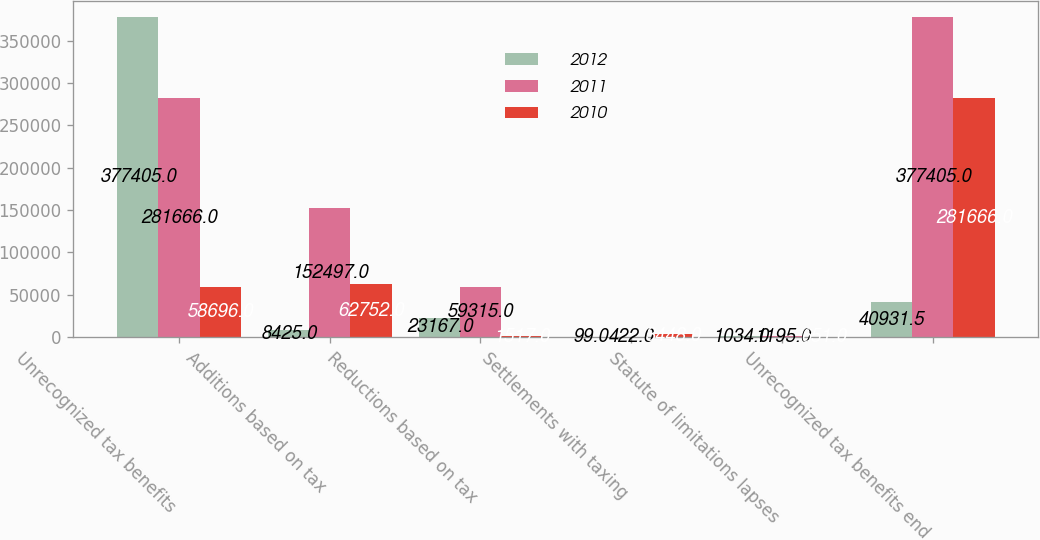Convert chart. <chart><loc_0><loc_0><loc_500><loc_500><stacked_bar_chart><ecel><fcel>Unrecognized tax benefits<fcel>Additions based on tax<fcel>Reductions based on tax<fcel>Settlements with taxing<fcel>Statute of limitations lapses<fcel>Unrecognized tax benefits end<nl><fcel>2012<fcel>377405<fcel>8425<fcel>23167<fcel>99<fcel>1034<fcel>40931.5<nl><fcel>2011<fcel>281666<fcel>152497<fcel>59315<fcel>422<fcel>1195<fcel>377405<nl><fcel>2010<fcel>58696<fcel>62752<fcel>1517<fcel>3448<fcel>651<fcel>281666<nl></chart> 